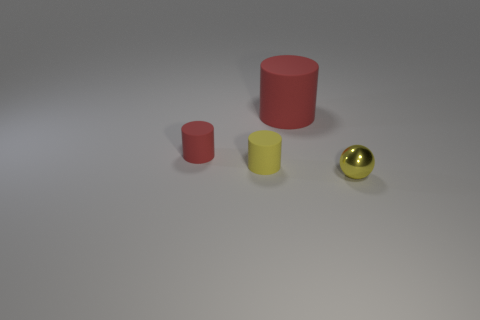Subtract all red cubes. How many red cylinders are left? 2 Subtract all red matte cylinders. How many cylinders are left? 1 Add 2 yellow matte objects. How many objects exist? 6 Subtract all purple cylinders. Subtract all gray spheres. How many cylinders are left? 3 Subtract all cylinders. How many objects are left? 1 Subtract all tiny blue blocks. Subtract all metallic objects. How many objects are left? 3 Add 4 yellow matte cylinders. How many yellow matte cylinders are left? 5 Add 2 yellow rubber objects. How many yellow rubber objects exist? 3 Subtract 0 blue cylinders. How many objects are left? 4 